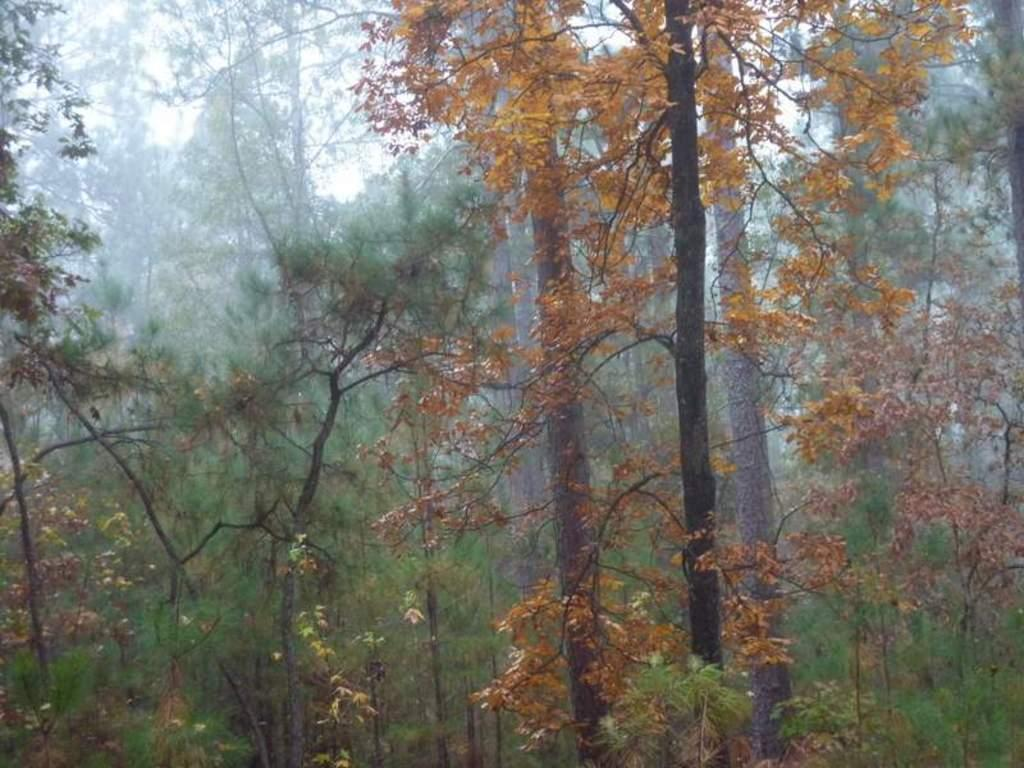What type of vegetation can be seen in the image? There are trees in the image. What can be seen in the sky in the image? There are clouds visible in the sky. What religion is practiced by the pet in the image? There is no pet present in the image, so it is not possible to determine the religion practiced by any pet. 